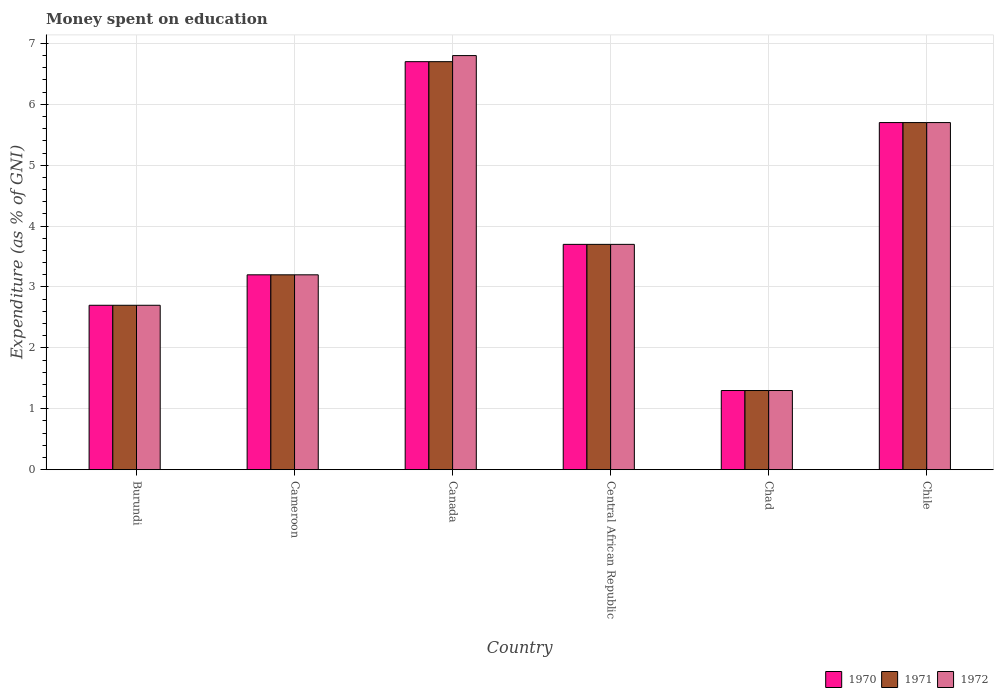How many different coloured bars are there?
Your answer should be very brief. 3. Are the number of bars on each tick of the X-axis equal?
Your answer should be very brief. Yes. How many bars are there on the 5th tick from the right?
Make the answer very short. 3. What is the label of the 1st group of bars from the left?
Offer a very short reply. Burundi. In how many cases, is the number of bars for a given country not equal to the number of legend labels?
Offer a very short reply. 0. Across all countries, what is the maximum amount of money spent on education in 1971?
Provide a succinct answer. 6.7. In which country was the amount of money spent on education in 1972 maximum?
Make the answer very short. Canada. In which country was the amount of money spent on education in 1972 minimum?
Provide a succinct answer. Chad. What is the total amount of money spent on education in 1971 in the graph?
Offer a very short reply. 23.3. What is the difference between the amount of money spent on education in 1971 in Chile and the amount of money spent on education in 1972 in Cameroon?
Offer a terse response. 2.5. What is the average amount of money spent on education in 1972 per country?
Your response must be concise. 3.9. What is the difference between the amount of money spent on education of/in 1971 and amount of money spent on education of/in 1972 in Canada?
Provide a short and direct response. -0.1. In how many countries, is the amount of money spent on education in 1971 greater than 0.8 %?
Give a very brief answer. 6. What is the ratio of the amount of money spent on education in 1971 in Cameroon to that in Canada?
Offer a very short reply. 0.48. Is the amount of money spent on education in 1972 in Cameroon less than that in Chile?
Offer a terse response. Yes. Is the difference between the amount of money spent on education in 1971 in Cameroon and Chile greater than the difference between the amount of money spent on education in 1972 in Cameroon and Chile?
Your answer should be very brief. No. What is the difference between the highest and the second highest amount of money spent on education in 1971?
Your answer should be compact. -2. In how many countries, is the amount of money spent on education in 1971 greater than the average amount of money spent on education in 1971 taken over all countries?
Provide a succinct answer. 2. Is the sum of the amount of money spent on education in 1972 in Cameroon and Chad greater than the maximum amount of money spent on education in 1971 across all countries?
Your answer should be very brief. No. What does the 3rd bar from the right in Central African Republic represents?
Give a very brief answer. 1970. How many bars are there?
Keep it short and to the point. 18. How many countries are there in the graph?
Keep it short and to the point. 6. What is the difference between two consecutive major ticks on the Y-axis?
Offer a very short reply. 1. Are the values on the major ticks of Y-axis written in scientific E-notation?
Make the answer very short. No. Where does the legend appear in the graph?
Make the answer very short. Bottom right. What is the title of the graph?
Provide a succinct answer. Money spent on education. What is the label or title of the Y-axis?
Ensure brevity in your answer.  Expenditure (as % of GNI). What is the Expenditure (as % of GNI) of 1971 in Cameroon?
Offer a very short reply. 3.2. What is the Expenditure (as % of GNI) in 1970 in Canada?
Offer a terse response. 6.7. What is the Expenditure (as % of GNI) of 1971 in Canada?
Your answer should be very brief. 6.7. What is the Expenditure (as % of GNI) of 1972 in Canada?
Provide a short and direct response. 6.8. What is the Expenditure (as % of GNI) in 1970 in Central African Republic?
Ensure brevity in your answer.  3.7. What is the Expenditure (as % of GNI) in 1972 in Central African Republic?
Give a very brief answer. 3.7. What is the Expenditure (as % of GNI) in 1972 in Chile?
Give a very brief answer. 5.7. Across all countries, what is the maximum Expenditure (as % of GNI) of 1971?
Give a very brief answer. 6.7. Across all countries, what is the minimum Expenditure (as % of GNI) in 1971?
Give a very brief answer. 1.3. Across all countries, what is the minimum Expenditure (as % of GNI) of 1972?
Your response must be concise. 1.3. What is the total Expenditure (as % of GNI) in 1970 in the graph?
Offer a terse response. 23.3. What is the total Expenditure (as % of GNI) in 1971 in the graph?
Make the answer very short. 23.3. What is the total Expenditure (as % of GNI) in 1972 in the graph?
Give a very brief answer. 23.4. What is the difference between the Expenditure (as % of GNI) in 1970 in Burundi and that in Cameroon?
Your response must be concise. -0.5. What is the difference between the Expenditure (as % of GNI) of 1970 in Burundi and that in Canada?
Provide a short and direct response. -4. What is the difference between the Expenditure (as % of GNI) of 1970 in Burundi and that in Central African Republic?
Keep it short and to the point. -1. What is the difference between the Expenditure (as % of GNI) of 1971 in Burundi and that in Central African Republic?
Provide a succinct answer. -1. What is the difference between the Expenditure (as % of GNI) in 1972 in Burundi and that in Central African Republic?
Offer a terse response. -1. What is the difference between the Expenditure (as % of GNI) in 1970 in Burundi and that in Chad?
Provide a succinct answer. 1.4. What is the difference between the Expenditure (as % of GNI) of 1972 in Burundi and that in Chad?
Keep it short and to the point. 1.4. What is the difference between the Expenditure (as % of GNI) in 1970 in Burundi and that in Chile?
Ensure brevity in your answer.  -3. What is the difference between the Expenditure (as % of GNI) in 1971 in Burundi and that in Chile?
Provide a short and direct response. -3. What is the difference between the Expenditure (as % of GNI) in 1970 in Cameroon and that in Canada?
Offer a very short reply. -3.5. What is the difference between the Expenditure (as % of GNI) in 1970 in Cameroon and that in Central African Republic?
Provide a short and direct response. -0.5. What is the difference between the Expenditure (as % of GNI) in 1972 in Cameroon and that in Central African Republic?
Keep it short and to the point. -0.5. What is the difference between the Expenditure (as % of GNI) of 1970 in Cameroon and that in Chad?
Ensure brevity in your answer.  1.9. What is the difference between the Expenditure (as % of GNI) in 1972 in Cameroon and that in Chad?
Ensure brevity in your answer.  1.9. What is the difference between the Expenditure (as % of GNI) in 1970 in Canada and that in Central African Republic?
Give a very brief answer. 3. What is the difference between the Expenditure (as % of GNI) of 1972 in Canada and that in Central African Republic?
Keep it short and to the point. 3.1. What is the difference between the Expenditure (as % of GNI) of 1970 in Canada and that in Chad?
Ensure brevity in your answer.  5.4. What is the difference between the Expenditure (as % of GNI) of 1971 in Canada and that in Chad?
Your answer should be very brief. 5.4. What is the difference between the Expenditure (as % of GNI) of 1970 in Canada and that in Chile?
Your answer should be very brief. 1. What is the difference between the Expenditure (as % of GNI) in 1971 in Canada and that in Chile?
Your answer should be compact. 1. What is the difference between the Expenditure (as % of GNI) in 1972 in Canada and that in Chile?
Give a very brief answer. 1.1. What is the difference between the Expenditure (as % of GNI) in 1970 in Central African Republic and that in Chad?
Make the answer very short. 2.4. What is the difference between the Expenditure (as % of GNI) of 1971 in Central African Republic and that in Chad?
Provide a short and direct response. 2.4. What is the difference between the Expenditure (as % of GNI) in 1972 in Central African Republic and that in Chad?
Make the answer very short. 2.4. What is the difference between the Expenditure (as % of GNI) in 1970 in Central African Republic and that in Chile?
Give a very brief answer. -2. What is the difference between the Expenditure (as % of GNI) of 1971 in Central African Republic and that in Chile?
Offer a very short reply. -2. What is the difference between the Expenditure (as % of GNI) of 1972 in Central African Republic and that in Chile?
Your response must be concise. -2. What is the difference between the Expenditure (as % of GNI) in 1970 in Chad and that in Chile?
Make the answer very short. -4.4. What is the difference between the Expenditure (as % of GNI) in 1970 in Burundi and the Expenditure (as % of GNI) in 1972 in Cameroon?
Keep it short and to the point. -0.5. What is the difference between the Expenditure (as % of GNI) in 1970 in Burundi and the Expenditure (as % of GNI) in 1972 in Canada?
Provide a succinct answer. -4.1. What is the difference between the Expenditure (as % of GNI) of 1971 in Burundi and the Expenditure (as % of GNI) of 1972 in Canada?
Give a very brief answer. -4.1. What is the difference between the Expenditure (as % of GNI) in 1970 in Burundi and the Expenditure (as % of GNI) in 1971 in Central African Republic?
Give a very brief answer. -1. What is the difference between the Expenditure (as % of GNI) of 1970 in Burundi and the Expenditure (as % of GNI) of 1972 in Central African Republic?
Your response must be concise. -1. What is the difference between the Expenditure (as % of GNI) of 1970 in Burundi and the Expenditure (as % of GNI) of 1972 in Chad?
Give a very brief answer. 1.4. What is the difference between the Expenditure (as % of GNI) in 1971 in Burundi and the Expenditure (as % of GNI) in 1972 in Chad?
Your answer should be compact. 1.4. What is the difference between the Expenditure (as % of GNI) in 1970 in Burundi and the Expenditure (as % of GNI) in 1971 in Chile?
Your response must be concise. -3. What is the difference between the Expenditure (as % of GNI) of 1970 in Burundi and the Expenditure (as % of GNI) of 1972 in Chile?
Provide a succinct answer. -3. What is the difference between the Expenditure (as % of GNI) of 1970 in Cameroon and the Expenditure (as % of GNI) of 1971 in Central African Republic?
Your answer should be very brief. -0.5. What is the difference between the Expenditure (as % of GNI) of 1970 in Cameroon and the Expenditure (as % of GNI) of 1972 in Chad?
Keep it short and to the point. 1.9. What is the difference between the Expenditure (as % of GNI) of 1971 in Cameroon and the Expenditure (as % of GNI) of 1972 in Chad?
Provide a short and direct response. 1.9. What is the difference between the Expenditure (as % of GNI) in 1970 in Canada and the Expenditure (as % of GNI) in 1971 in Central African Republic?
Your answer should be very brief. 3. What is the difference between the Expenditure (as % of GNI) in 1970 in Canada and the Expenditure (as % of GNI) in 1972 in Central African Republic?
Offer a very short reply. 3. What is the difference between the Expenditure (as % of GNI) of 1970 in Canada and the Expenditure (as % of GNI) of 1971 in Chad?
Provide a short and direct response. 5.4. What is the difference between the Expenditure (as % of GNI) of 1970 in Canada and the Expenditure (as % of GNI) of 1971 in Chile?
Offer a terse response. 1. What is the difference between the Expenditure (as % of GNI) of 1970 in Canada and the Expenditure (as % of GNI) of 1972 in Chile?
Keep it short and to the point. 1. What is the difference between the Expenditure (as % of GNI) in 1971 in Canada and the Expenditure (as % of GNI) in 1972 in Chile?
Offer a terse response. 1. What is the difference between the Expenditure (as % of GNI) in 1970 in Central African Republic and the Expenditure (as % of GNI) in 1972 in Chile?
Offer a terse response. -2. What is the average Expenditure (as % of GNI) in 1970 per country?
Provide a succinct answer. 3.88. What is the average Expenditure (as % of GNI) of 1971 per country?
Ensure brevity in your answer.  3.88. What is the difference between the Expenditure (as % of GNI) of 1970 and Expenditure (as % of GNI) of 1971 in Cameroon?
Make the answer very short. 0. What is the difference between the Expenditure (as % of GNI) in 1970 and Expenditure (as % of GNI) in 1972 in Cameroon?
Ensure brevity in your answer.  0. What is the difference between the Expenditure (as % of GNI) of 1970 and Expenditure (as % of GNI) of 1971 in Canada?
Offer a very short reply. 0. What is the difference between the Expenditure (as % of GNI) of 1971 and Expenditure (as % of GNI) of 1972 in Canada?
Make the answer very short. -0.1. What is the difference between the Expenditure (as % of GNI) in 1970 and Expenditure (as % of GNI) in 1972 in Central African Republic?
Offer a terse response. 0. What is the difference between the Expenditure (as % of GNI) of 1971 and Expenditure (as % of GNI) of 1972 in Central African Republic?
Provide a short and direct response. 0. What is the difference between the Expenditure (as % of GNI) of 1970 and Expenditure (as % of GNI) of 1971 in Chad?
Make the answer very short. 0. What is the difference between the Expenditure (as % of GNI) of 1970 and Expenditure (as % of GNI) of 1972 in Chad?
Make the answer very short. 0. What is the difference between the Expenditure (as % of GNI) in 1971 and Expenditure (as % of GNI) in 1972 in Chad?
Ensure brevity in your answer.  0. What is the difference between the Expenditure (as % of GNI) in 1970 and Expenditure (as % of GNI) in 1971 in Chile?
Your answer should be very brief. 0. What is the ratio of the Expenditure (as % of GNI) in 1970 in Burundi to that in Cameroon?
Offer a terse response. 0.84. What is the ratio of the Expenditure (as % of GNI) in 1971 in Burundi to that in Cameroon?
Make the answer very short. 0.84. What is the ratio of the Expenditure (as % of GNI) of 1972 in Burundi to that in Cameroon?
Provide a short and direct response. 0.84. What is the ratio of the Expenditure (as % of GNI) of 1970 in Burundi to that in Canada?
Keep it short and to the point. 0.4. What is the ratio of the Expenditure (as % of GNI) of 1971 in Burundi to that in Canada?
Make the answer very short. 0.4. What is the ratio of the Expenditure (as % of GNI) in 1972 in Burundi to that in Canada?
Your answer should be compact. 0.4. What is the ratio of the Expenditure (as % of GNI) in 1970 in Burundi to that in Central African Republic?
Give a very brief answer. 0.73. What is the ratio of the Expenditure (as % of GNI) of 1971 in Burundi to that in Central African Republic?
Give a very brief answer. 0.73. What is the ratio of the Expenditure (as % of GNI) of 1972 in Burundi to that in Central African Republic?
Your answer should be compact. 0.73. What is the ratio of the Expenditure (as % of GNI) in 1970 in Burundi to that in Chad?
Your response must be concise. 2.08. What is the ratio of the Expenditure (as % of GNI) of 1971 in Burundi to that in Chad?
Offer a terse response. 2.08. What is the ratio of the Expenditure (as % of GNI) in 1972 in Burundi to that in Chad?
Offer a very short reply. 2.08. What is the ratio of the Expenditure (as % of GNI) of 1970 in Burundi to that in Chile?
Ensure brevity in your answer.  0.47. What is the ratio of the Expenditure (as % of GNI) in 1971 in Burundi to that in Chile?
Make the answer very short. 0.47. What is the ratio of the Expenditure (as % of GNI) in 1972 in Burundi to that in Chile?
Provide a short and direct response. 0.47. What is the ratio of the Expenditure (as % of GNI) in 1970 in Cameroon to that in Canada?
Your answer should be very brief. 0.48. What is the ratio of the Expenditure (as % of GNI) in 1971 in Cameroon to that in Canada?
Your answer should be very brief. 0.48. What is the ratio of the Expenditure (as % of GNI) of 1972 in Cameroon to that in Canada?
Offer a very short reply. 0.47. What is the ratio of the Expenditure (as % of GNI) in 1970 in Cameroon to that in Central African Republic?
Your response must be concise. 0.86. What is the ratio of the Expenditure (as % of GNI) of 1971 in Cameroon to that in Central African Republic?
Ensure brevity in your answer.  0.86. What is the ratio of the Expenditure (as % of GNI) of 1972 in Cameroon to that in Central African Republic?
Provide a short and direct response. 0.86. What is the ratio of the Expenditure (as % of GNI) in 1970 in Cameroon to that in Chad?
Keep it short and to the point. 2.46. What is the ratio of the Expenditure (as % of GNI) of 1971 in Cameroon to that in Chad?
Offer a terse response. 2.46. What is the ratio of the Expenditure (as % of GNI) of 1972 in Cameroon to that in Chad?
Your answer should be very brief. 2.46. What is the ratio of the Expenditure (as % of GNI) in 1970 in Cameroon to that in Chile?
Offer a terse response. 0.56. What is the ratio of the Expenditure (as % of GNI) in 1971 in Cameroon to that in Chile?
Offer a terse response. 0.56. What is the ratio of the Expenditure (as % of GNI) in 1972 in Cameroon to that in Chile?
Your answer should be very brief. 0.56. What is the ratio of the Expenditure (as % of GNI) of 1970 in Canada to that in Central African Republic?
Ensure brevity in your answer.  1.81. What is the ratio of the Expenditure (as % of GNI) in 1971 in Canada to that in Central African Republic?
Offer a terse response. 1.81. What is the ratio of the Expenditure (as % of GNI) of 1972 in Canada to that in Central African Republic?
Your response must be concise. 1.84. What is the ratio of the Expenditure (as % of GNI) of 1970 in Canada to that in Chad?
Provide a succinct answer. 5.15. What is the ratio of the Expenditure (as % of GNI) in 1971 in Canada to that in Chad?
Keep it short and to the point. 5.15. What is the ratio of the Expenditure (as % of GNI) of 1972 in Canada to that in Chad?
Your answer should be very brief. 5.23. What is the ratio of the Expenditure (as % of GNI) of 1970 in Canada to that in Chile?
Offer a very short reply. 1.18. What is the ratio of the Expenditure (as % of GNI) of 1971 in Canada to that in Chile?
Keep it short and to the point. 1.18. What is the ratio of the Expenditure (as % of GNI) of 1972 in Canada to that in Chile?
Give a very brief answer. 1.19. What is the ratio of the Expenditure (as % of GNI) in 1970 in Central African Republic to that in Chad?
Your answer should be compact. 2.85. What is the ratio of the Expenditure (as % of GNI) in 1971 in Central African Republic to that in Chad?
Your answer should be compact. 2.85. What is the ratio of the Expenditure (as % of GNI) of 1972 in Central African Republic to that in Chad?
Keep it short and to the point. 2.85. What is the ratio of the Expenditure (as % of GNI) in 1970 in Central African Republic to that in Chile?
Offer a terse response. 0.65. What is the ratio of the Expenditure (as % of GNI) in 1971 in Central African Republic to that in Chile?
Make the answer very short. 0.65. What is the ratio of the Expenditure (as % of GNI) in 1972 in Central African Republic to that in Chile?
Ensure brevity in your answer.  0.65. What is the ratio of the Expenditure (as % of GNI) of 1970 in Chad to that in Chile?
Ensure brevity in your answer.  0.23. What is the ratio of the Expenditure (as % of GNI) in 1971 in Chad to that in Chile?
Offer a very short reply. 0.23. What is the ratio of the Expenditure (as % of GNI) in 1972 in Chad to that in Chile?
Provide a short and direct response. 0.23. What is the difference between the highest and the second highest Expenditure (as % of GNI) in 1970?
Provide a succinct answer. 1. What is the difference between the highest and the second highest Expenditure (as % of GNI) in 1972?
Keep it short and to the point. 1.1. What is the difference between the highest and the lowest Expenditure (as % of GNI) of 1971?
Your response must be concise. 5.4. 